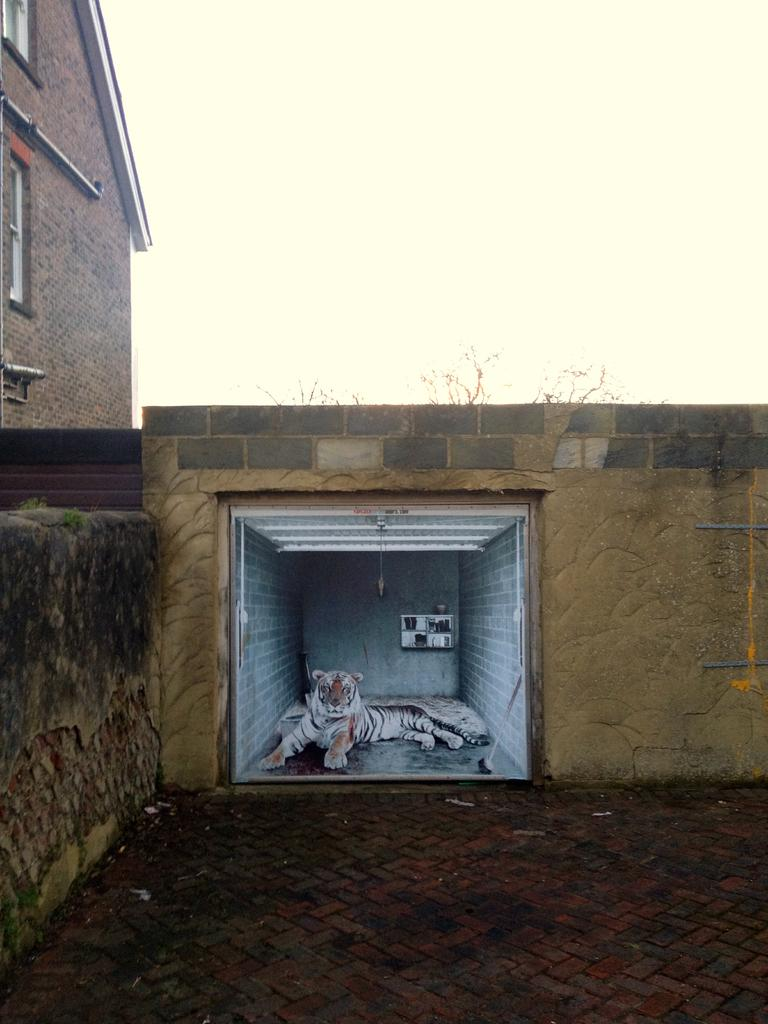What type of animal is in the room in the image? There is a tiger in the room in the image. What can be seen in the background of the image? There is a building and tree branches visible in the background of the image. How much money is on the stage in the image? There is no stage or money present in the image; it features a tiger in a room with a background of a building and tree branches. 